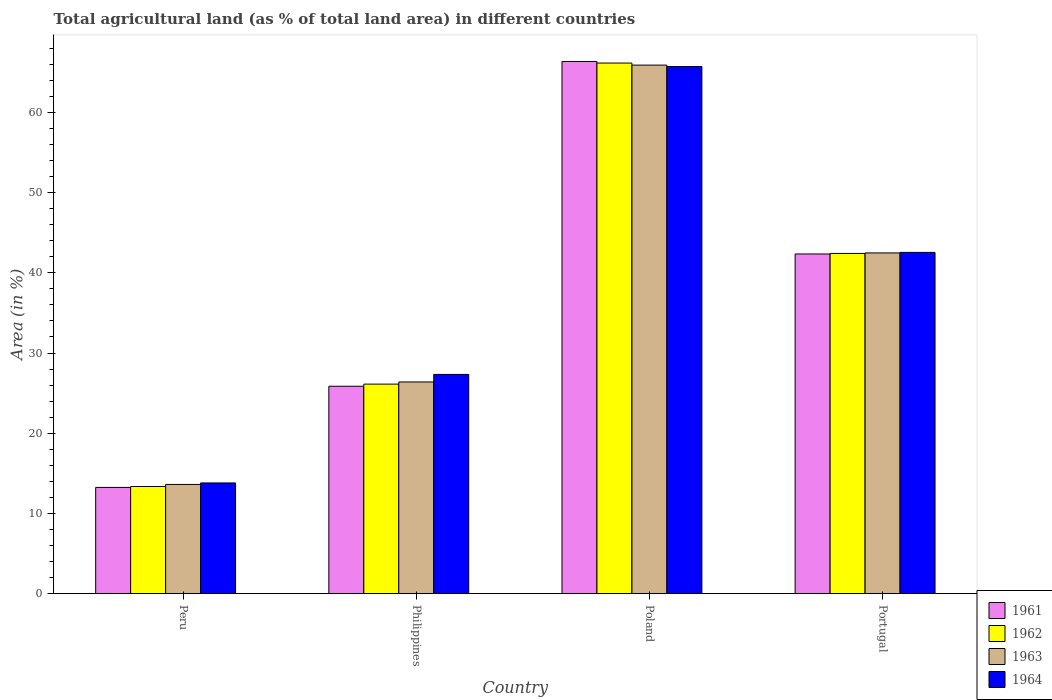Are the number of bars on each tick of the X-axis equal?
Provide a short and direct response. Yes. How many bars are there on the 1st tick from the left?
Ensure brevity in your answer.  4. What is the label of the 2nd group of bars from the left?
Your answer should be very brief. Philippines. In how many cases, is the number of bars for a given country not equal to the number of legend labels?
Keep it short and to the point. 0. What is the percentage of agricultural land in 1964 in Poland?
Give a very brief answer. 65.72. Across all countries, what is the maximum percentage of agricultural land in 1963?
Provide a short and direct response. 65.9. Across all countries, what is the minimum percentage of agricultural land in 1963?
Give a very brief answer. 13.62. In which country was the percentage of agricultural land in 1961 maximum?
Offer a terse response. Poland. What is the total percentage of agricultural land in 1964 in the graph?
Offer a terse response. 149.4. What is the difference between the percentage of agricultural land in 1964 in Peru and that in Portugal?
Provide a succinct answer. -28.74. What is the difference between the percentage of agricultural land in 1964 in Poland and the percentage of agricultural land in 1961 in Portugal?
Give a very brief answer. 23.37. What is the average percentage of agricultural land in 1964 per country?
Keep it short and to the point. 37.35. What is the difference between the percentage of agricultural land of/in 1963 and percentage of agricultural land of/in 1964 in Peru?
Offer a very short reply. -0.19. What is the ratio of the percentage of agricultural land in 1964 in Peru to that in Poland?
Keep it short and to the point. 0.21. Is the difference between the percentage of agricultural land in 1963 in Peru and Philippines greater than the difference between the percentage of agricultural land in 1964 in Peru and Philippines?
Your answer should be very brief. Yes. What is the difference between the highest and the second highest percentage of agricultural land in 1962?
Provide a short and direct response. 40.03. What is the difference between the highest and the lowest percentage of agricultural land in 1961?
Your answer should be compact. 53.1. What does the 2nd bar from the left in Poland represents?
Provide a short and direct response. 1962. What does the 4th bar from the right in Portugal represents?
Offer a terse response. 1961. Is it the case that in every country, the sum of the percentage of agricultural land in 1964 and percentage of agricultural land in 1962 is greater than the percentage of agricultural land in 1963?
Make the answer very short. Yes. What is the difference between two consecutive major ticks on the Y-axis?
Offer a very short reply. 10. How many legend labels are there?
Your answer should be compact. 4. How are the legend labels stacked?
Offer a very short reply. Vertical. What is the title of the graph?
Ensure brevity in your answer.  Total agricultural land (as % of total land area) in different countries. Does "2001" appear as one of the legend labels in the graph?
Provide a short and direct response. No. What is the label or title of the Y-axis?
Make the answer very short. Area (in %). What is the Area (in %) of 1961 in Peru?
Ensure brevity in your answer.  13.25. What is the Area (in %) of 1962 in Peru?
Offer a very short reply. 13.36. What is the Area (in %) of 1963 in Peru?
Give a very brief answer. 13.62. What is the Area (in %) in 1964 in Peru?
Ensure brevity in your answer.  13.8. What is the Area (in %) in 1961 in Philippines?
Provide a short and direct response. 25.86. What is the Area (in %) of 1962 in Philippines?
Your answer should be very brief. 26.12. What is the Area (in %) in 1963 in Philippines?
Your answer should be compact. 26.39. What is the Area (in %) of 1964 in Philippines?
Your response must be concise. 27.33. What is the Area (in %) in 1961 in Poland?
Provide a short and direct response. 66.35. What is the Area (in %) of 1962 in Poland?
Provide a succinct answer. 66.15. What is the Area (in %) in 1963 in Poland?
Your response must be concise. 65.9. What is the Area (in %) in 1964 in Poland?
Make the answer very short. 65.72. What is the Area (in %) in 1961 in Portugal?
Keep it short and to the point. 42.35. What is the Area (in %) of 1962 in Portugal?
Offer a very short reply. 42.42. What is the Area (in %) in 1963 in Portugal?
Provide a succinct answer. 42.48. What is the Area (in %) of 1964 in Portugal?
Give a very brief answer. 42.55. Across all countries, what is the maximum Area (in %) of 1961?
Ensure brevity in your answer.  66.35. Across all countries, what is the maximum Area (in %) in 1962?
Your response must be concise. 66.15. Across all countries, what is the maximum Area (in %) of 1963?
Provide a short and direct response. 65.9. Across all countries, what is the maximum Area (in %) in 1964?
Offer a very short reply. 65.72. Across all countries, what is the minimum Area (in %) of 1961?
Your answer should be very brief. 13.25. Across all countries, what is the minimum Area (in %) of 1962?
Provide a short and direct response. 13.36. Across all countries, what is the minimum Area (in %) of 1963?
Offer a very short reply. 13.62. Across all countries, what is the minimum Area (in %) in 1964?
Provide a succinct answer. 13.8. What is the total Area (in %) in 1961 in the graph?
Provide a succinct answer. 147.81. What is the total Area (in %) in 1962 in the graph?
Offer a terse response. 148.05. What is the total Area (in %) in 1963 in the graph?
Offer a terse response. 148.39. What is the total Area (in %) in 1964 in the graph?
Your answer should be very brief. 149.4. What is the difference between the Area (in %) of 1961 in Peru and that in Philippines?
Give a very brief answer. -12.61. What is the difference between the Area (in %) of 1962 in Peru and that in Philippines?
Your answer should be very brief. -12.77. What is the difference between the Area (in %) in 1963 in Peru and that in Philippines?
Your answer should be compact. -12.78. What is the difference between the Area (in %) in 1964 in Peru and that in Philippines?
Offer a very short reply. -13.53. What is the difference between the Area (in %) in 1961 in Peru and that in Poland?
Offer a very short reply. -53.1. What is the difference between the Area (in %) in 1962 in Peru and that in Poland?
Provide a short and direct response. -52.79. What is the difference between the Area (in %) in 1963 in Peru and that in Poland?
Offer a terse response. -52.28. What is the difference between the Area (in %) of 1964 in Peru and that in Poland?
Make the answer very short. -51.92. What is the difference between the Area (in %) in 1961 in Peru and that in Portugal?
Provide a succinct answer. -29.1. What is the difference between the Area (in %) of 1962 in Peru and that in Portugal?
Provide a short and direct response. -29.06. What is the difference between the Area (in %) of 1963 in Peru and that in Portugal?
Offer a very short reply. -28.86. What is the difference between the Area (in %) of 1964 in Peru and that in Portugal?
Give a very brief answer. -28.74. What is the difference between the Area (in %) of 1961 in Philippines and that in Poland?
Give a very brief answer. -40.49. What is the difference between the Area (in %) of 1962 in Philippines and that in Poland?
Keep it short and to the point. -40.03. What is the difference between the Area (in %) in 1963 in Philippines and that in Poland?
Make the answer very short. -39.51. What is the difference between the Area (in %) in 1964 in Philippines and that in Poland?
Offer a very short reply. -38.39. What is the difference between the Area (in %) in 1961 in Philippines and that in Portugal?
Provide a succinct answer. -16.49. What is the difference between the Area (in %) in 1962 in Philippines and that in Portugal?
Provide a short and direct response. -16.29. What is the difference between the Area (in %) of 1963 in Philippines and that in Portugal?
Give a very brief answer. -16.09. What is the difference between the Area (in %) in 1964 in Philippines and that in Portugal?
Ensure brevity in your answer.  -15.21. What is the difference between the Area (in %) in 1961 in Poland and that in Portugal?
Your answer should be very brief. 24. What is the difference between the Area (in %) of 1962 in Poland and that in Portugal?
Your response must be concise. 23.74. What is the difference between the Area (in %) of 1963 in Poland and that in Portugal?
Your answer should be compact. 23.42. What is the difference between the Area (in %) of 1964 in Poland and that in Portugal?
Provide a short and direct response. 23.18. What is the difference between the Area (in %) in 1961 in Peru and the Area (in %) in 1962 in Philippines?
Make the answer very short. -12.88. What is the difference between the Area (in %) of 1961 in Peru and the Area (in %) of 1963 in Philippines?
Keep it short and to the point. -13.15. What is the difference between the Area (in %) of 1961 in Peru and the Area (in %) of 1964 in Philippines?
Offer a terse response. -14.09. What is the difference between the Area (in %) of 1962 in Peru and the Area (in %) of 1963 in Philippines?
Provide a short and direct response. -13.03. What is the difference between the Area (in %) in 1962 in Peru and the Area (in %) in 1964 in Philippines?
Offer a very short reply. -13.97. What is the difference between the Area (in %) in 1963 in Peru and the Area (in %) in 1964 in Philippines?
Offer a very short reply. -13.71. What is the difference between the Area (in %) in 1961 in Peru and the Area (in %) in 1962 in Poland?
Provide a succinct answer. -52.91. What is the difference between the Area (in %) of 1961 in Peru and the Area (in %) of 1963 in Poland?
Your answer should be compact. -52.65. What is the difference between the Area (in %) in 1961 in Peru and the Area (in %) in 1964 in Poland?
Your answer should be very brief. -52.48. What is the difference between the Area (in %) of 1962 in Peru and the Area (in %) of 1963 in Poland?
Your response must be concise. -52.54. What is the difference between the Area (in %) in 1962 in Peru and the Area (in %) in 1964 in Poland?
Give a very brief answer. -52.36. What is the difference between the Area (in %) of 1963 in Peru and the Area (in %) of 1964 in Poland?
Offer a terse response. -52.1. What is the difference between the Area (in %) of 1961 in Peru and the Area (in %) of 1962 in Portugal?
Your answer should be compact. -29.17. What is the difference between the Area (in %) in 1961 in Peru and the Area (in %) in 1963 in Portugal?
Ensure brevity in your answer.  -29.23. What is the difference between the Area (in %) of 1961 in Peru and the Area (in %) of 1964 in Portugal?
Provide a succinct answer. -29.3. What is the difference between the Area (in %) of 1962 in Peru and the Area (in %) of 1963 in Portugal?
Provide a short and direct response. -29.12. What is the difference between the Area (in %) of 1962 in Peru and the Area (in %) of 1964 in Portugal?
Offer a terse response. -29.19. What is the difference between the Area (in %) of 1963 in Peru and the Area (in %) of 1964 in Portugal?
Provide a succinct answer. -28.93. What is the difference between the Area (in %) of 1961 in Philippines and the Area (in %) of 1962 in Poland?
Keep it short and to the point. -40.29. What is the difference between the Area (in %) in 1961 in Philippines and the Area (in %) in 1963 in Poland?
Your answer should be compact. -40.04. What is the difference between the Area (in %) of 1961 in Philippines and the Area (in %) of 1964 in Poland?
Provide a succinct answer. -39.86. What is the difference between the Area (in %) of 1962 in Philippines and the Area (in %) of 1963 in Poland?
Your response must be concise. -39.77. What is the difference between the Area (in %) of 1962 in Philippines and the Area (in %) of 1964 in Poland?
Your answer should be very brief. -39.6. What is the difference between the Area (in %) of 1963 in Philippines and the Area (in %) of 1964 in Poland?
Keep it short and to the point. -39.33. What is the difference between the Area (in %) in 1961 in Philippines and the Area (in %) in 1962 in Portugal?
Make the answer very short. -16.56. What is the difference between the Area (in %) in 1961 in Philippines and the Area (in %) in 1963 in Portugal?
Ensure brevity in your answer.  -16.62. What is the difference between the Area (in %) of 1961 in Philippines and the Area (in %) of 1964 in Portugal?
Offer a very short reply. -16.69. What is the difference between the Area (in %) of 1962 in Philippines and the Area (in %) of 1963 in Portugal?
Your answer should be very brief. -16.36. What is the difference between the Area (in %) of 1962 in Philippines and the Area (in %) of 1964 in Portugal?
Your response must be concise. -16.42. What is the difference between the Area (in %) in 1963 in Philippines and the Area (in %) in 1964 in Portugal?
Your answer should be very brief. -16.15. What is the difference between the Area (in %) in 1961 in Poland and the Area (in %) in 1962 in Portugal?
Provide a short and direct response. 23.93. What is the difference between the Area (in %) of 1961 in Poland and the Area (in %) of 1963 in Portugal?
Your answer should be compact. 23.87. What is the difference between the Area (in %) of 1961 in Poland and the Area (in %) of 1964 in Portugal?
Provide a short and direct response. 23.8. What is the difference between the Area (in %) in 1962 in Poland and the Area (in %) in 1963 in Portugal?
Give a very brief answer. 23.67. What is the difference between the Area (in %) in 1962 in Poland and the Area (in %) in 1964 in Portugal?
Provide a succinct answer. 23.61. What is the difference between the Area (in %) of 1963 in Poland and the Area (in %) of 1964 in Portugal?
Give a very brief answer. 23.35. What is the average Area (in %) of 1961 per country?
Provide a short and direct response. 36.95. What is the average Area (in %) of 1962 per country?
Your answer should be very brief. 37.01. What is the average Area (in %) of 1963 per country?
Ensure brevity in your answer.  37.1. What is the average Area (in %) of 1964 per country?
Your answer should be compact. 37.35. What is the difference between the Area (in %) in 1961 and Area (in %) in 1962 in Peru?
Ensure brevity in your answer.  -0.11. What is the difference between the Area (in %) of 1961 and Area (in %) of 1963 in Peru?
Offer a terse response. -0.37. What is the difference between the Area (in %) in 1961 and Area (in %) in 1964 in Peru?
Ensure brevity in your answer.  -0.56. What is the difference between the Area (in %) in 1962 and Area (in %) in 1963 in Peru?
Your answer should be compact. -0.26. What is the difference between the Area (in %) in 1962 and Area (in %) in 1964 in Peru?
Offer a very short reply. -0.44. What is the difference between the Area (in %) of 1963 and Area (in %) of 1964 in Peru?
Offer a terse response. -0.19. What is the difference between the Area (in %) of 1961 and Area (in %) of 1962 in Philippines?
Your response must be concise. -0.26. What is the difference between the Area (in %) of 1961 and Area (in %) of 1963 in Philippines?
Your answer should be very brief. -0.53. What is the difference between the Area (in %) in 1961 and Area (in %) in 1964 in Philippines?
Make the answer very short. -1.47. What is the difference between the Area (in %) in 1962 and Area (in %) in 1963 in Philippines?
Offer a very short reply. -0.27. What is the difference between the Area (in %) of 1962 and Area (in %) of 1964 in Philippines?
Provide a succinct answer. -1.21. What is the difference between the Area (in %) of 1963 and Area (in %) of 1964 in Philippines?
Provide a short and direct response. -0.94. What is the difference between the Area (in %) of 1961 and Area (in %) of 1962 in Poland?
Your answer should be compact. 0.2. What is the difference between the Area (in %) in 1961 and Area (in %) in 1963 in Poland?
Make the answer very short. 0.45. What is the difference between the Area (in %) in 1961 and Area (in %) in 1964 in Poland?
Give a very brief answer. 0.63. What is the difference between the Area (in %) of 1962 and Area (in %) of 1963 in Poland?
Give a very brief answer. 0.25. What is the difference between the Area (in %) of 1962 and Area (in %) of 1964 in Poland?
Provide a succinct answer. 0.43. What is the difference between the Area (in %) in 1963 and Area (in %) in 1964 in Poland?
Offer a terse response. 0.18. What is the difference between the Area (in %) of 1961 and Area (in %) of 1962 in Portugal?
Make the answer very short. -0.07. What is the difference between the Area (in %) in 1961 and Area (in %) in 1963 in Portugal?
Your response must be concise. -0.13. What is the difference between the Area (in %) in 1961 and Area (in %) in 1964 in Portugal?
Provide a succinct answer. -0.2. What is the difference between the Area (in %) of 1962 and Area (in %) of 1963 in Portugal?
Your answer should be compact. -0.07. What is the difference between the Area (in %) of 1962 and Area (in %) of 1964 in Portugal?
Ensure brevity in your answer.  -0.13. What is the difference between the Area (in %) in 1963 and Area (in %) in 1964 in Portugal?
Make the answer very short. -0.07. What is the ratio of the Area (in %) in 1961 in Peru to that in Philippines?
Keep it short and to the point. 0.51. What is the ratio of the Area (in %) in 1962 in Peru to that in Philippines?
Make the answer very short. 0.51. What is the ratio of the Area (in %) in 1963 in Peru to that in Philippines?
Keep it short and to the point. 0.52. What is the ratio of the Area (in %) in 1964 in Peru to that in Philippines?
Offer a very short reply. 0.51. What is the ratio of the Area (in %) in 1961 in Peru to that in Poland?
Provide a succinct answer. 0.2. What is the ratio of the Area (in %) of 1962 in Peru to that in Poland?
Ensure brevity in your answer.  0.2. What is the ratio of the Area (in %) in 1963 in Peru to that in Poland?
Provide a succinct answer. 0.21. What is the ratio of the Area (in %) in 1964 in Peru to that in Poland?
Keep it short and to the point. 0.21. What is the ratio of the Area (in %) of 1961 in Peru to that in Portugal?
Provide a succinct answer. 0.31. What is the ratio of the Area (in %) in 1962 in Peru to that in Portugal?
Your response must be concise. 0.31. What is the ratio of the Area (in %) in 1963 in Peru to that in Portugal?
Make the answer very short. 0.32. What is the ratio of the Area (in %) in 1964 in Peru to that in Portugal?
Your answer should be very brief. 0.32. What is the ratio of the Area (in %) of 1961 in Philippines to that in Poland?
Ensure brevity in your answer.  0.39. What is the ratio of the Area (in %) in 1962 in Philippines to that in Poland?
Your response must be concise. 0.39. What is the ratio of the Area (in %) in 1963 in Philippines to that in Poland?
Give a very brief answer. 0.4. What is the ratio of the Area (in %) in 1964 in Philippines to that in Poland?
Your answer should be very brief. 0.42. What is the ratio of the Area (in %) of 1961 in Philippines to that in Portugal?
Your answer should be very brief. 0.61. What is the ratio of the Area (in %) of 1962 in Philippines to that in Portugal?
Make the answer very short. 0.62. What is the ratio of the Area (in %) in 1963 in Philippines to that in Portugal?
Your answer should be very brief. 0.62. What is the ratio of the Area (in %) of 1964 in Philippines to that in Portugal?
Your response must be concise. 0.64. What is the ratio of the Area (in %) in 1961 in Poland to that in Portugal?
Give a very brief answer. 1.57. What is the ratio of the Area (in %) of 1962 in Poland to that in Portugal?
Your answer should be very brief. 1.56. What is the ratio of the Area (in %) of 1963 in Poland to that in Portugal?
Make the answer very short. 1.55. What is the ratio of the Area (in %) in 1964 in Poland to that in Portugal?
Give a very brief answer. 1.54. What is the difference between the highest and the second highest Area (in %) in 1961?
Keep it short and to the point. 24. What is the difference between the highest and the second highest Area (in %) in 1962?
Give a very brief answer. 23.74. What is the difference between the highest and the second highest Area (in %) of 1963?
Provide a succinct answer. 23.42. What is the difference between the highest and the second highest Area (in %) of 1964?
Keep it short and to the point. 23.18. What is the difference between the highest and the lowest Area (in %) in 1961?
Ensure brevity in your answer.  53.1. What is the difference between the highest and the lowest Area (in %) in 1962?
Your answer should be compact. 52.79. What is the difference between the highest and the lowest Area (in %) in 1963?
Make the answer very short. 52.28. What is the difference between the highest and the lowest Area (in %) in 1964?
Ensure brevity in your answer.  51.92. 